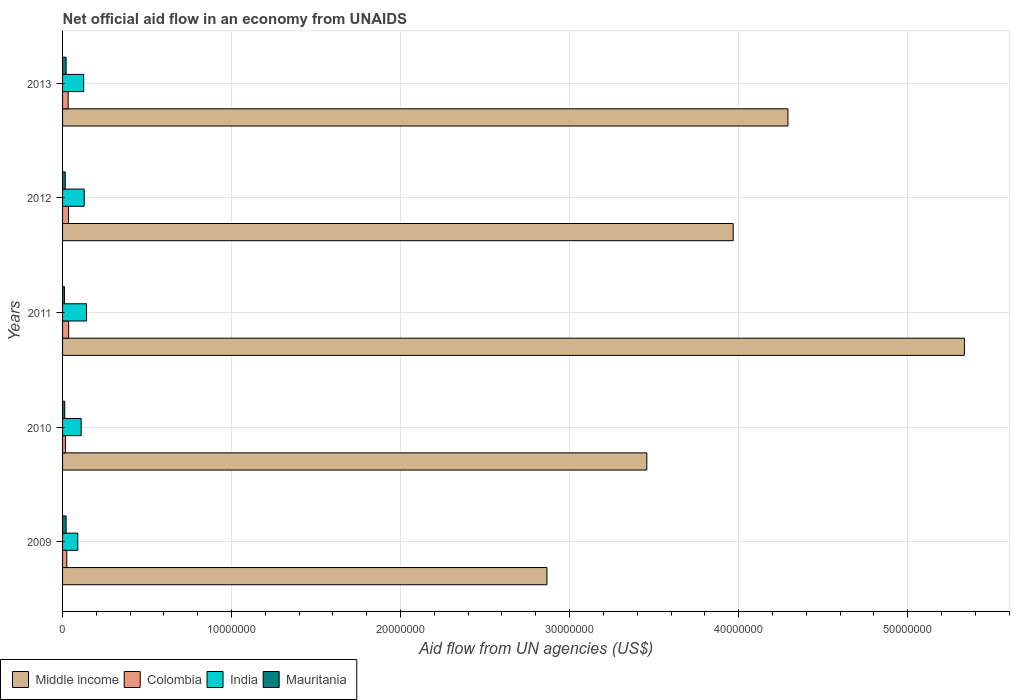How many different coloured bars are there?
Give a very brief answer. 4. Are the number of bars per tick equal to the number of legend labels?
Offer a very short reply. Yes. In how many cases, is the number of bars for a given year not equal to the number of legend labels?
Ensure brevity in your answer.  0. What is the net official aid flow in Middle income in 2009?
Offer a terse response. 2.87e+07. Across all years, what is the maximum net official aid flow in Middle income?
Your answer should be very brief. 5.34e+07. Across all years, what is the minimum net official aid flow in India?
Your answer should be very brief. 9.00e+05. In which year was the net official aid flow in Mauritania maximum?
Give a very brief answer. 2009. In which year was the net official aid flow in Mauritania minimum?
Offer a terse response. 2011. What is the total net official aid flow in Colombia in the graph?
Give a very brief answer. 1.46e+06. What is the difference between the net official aid flow in Colombia in 2010 and that in 2012?
Your answer should be compact. -1.80e+05. What is the difference between the net official aid flow in Colombia in 2011 and the net official aid flow in India in 2013?
Provide a succinct answer. -8.90e+05. What is the average net official aid flow in India per year?
Your answer should be compact. 1.19e+06. In the year 2012, what is the difference between the net official aid flow in Mauritania and net official aid flow in Middle income?
Make the answer very short. -3.95e+07. In how many years, is the net official aid flow in Colombia greater than 32000000 US$?
Make the answer very short. 0. What is the ratio of the net official aid flow in Middle income in 2009 to that in 2011?
Make the answer very short. 0.54. Is the difference between the net official aid flow in Mauritania in 2011 and 2013 greater than the difference between the net official aid flow in Middle income in 2011 and 2013?
Your response must be concise. No. What is the difference between the highest and the lowest net official aid flow in India?
Give a very brief answer. 5.20e+05. In how many years, is the net official aid flow in Colombia greater than the average net official aid flow in Colombia taken over all years?
Your response must be concise. 3. Is the sum of the net official aid flow in Mauritania in 2010 and 2012 greater than the maximum net official aid flow in Middle income across all years?
Offer a very short reply. No. What does the 4th bar from the bottom in 2011 represents?
Give a very brief answer. Mauritania. Is it the case that in every year, the sum of the net official aid flow in India and net official aid flow in Middle income is greater than the net official aid flow in Mauritania?
Provide a short and direct response. Yes. How many bars are there?
Ensure brevity in your answer.  20. Are all the bars in the graph horizontal?
Offer a very short reply. Yes. How many years are there in the graph?
Ensure brevity in your answer.  5. What is the difference between two consecutive major ticks on the X-axis?
Offer a terse response. 1.00e+07. Does the graph contain grids?
Offer a very short reply. Yes. Where does the legend appear in the graph?
Offer a very short reply. Bottom left. What is the title of the graph?
Offer a terse response. Net official aid flow in an economy from UNAIDS. Does "Barbados" appear as one of the legend labels in the graph?
Your response must be concise. No. What is the label or title of the X-axis?
Give a very brief answer. Aid flow from UN agencies (US$). What is the label or title of the Y-axis?
Provide a succinct answer. Years. What is the Aid flow from UN agencies (US$) in Middle income in 2009?
Keep it short and to the point. 2.87e+07. What is the Aid flow from UN agencies (US$) in Middle income in 2010?
Your answer should be compact. 3.46e+07. What is the Aid flow from UN agencies (US$) in India in 2010?
Ensure brevity in your answer.  1.10e+06. What is the Aid flow from UN agencies (US$) of Mauritania in 2010?
Make the answer very short. 1.30e+05. What is the Aid flow from UN agencies (US$) of Middle income in 2011?
Offer a very short reply. 5.34e+07. What is the Aid flow from UN agencies (US$) in India in 2011?
Ensure brevity in your answer.  1.42e+06. What is the Aid flow from UN agencies (US$) of Mauritania in 2011?
Offer a terse response. 1.10e+05. What is the Aid flow from UN agencies (US$) in Middle income in 2012?
Give a very brief answer. 3.97e+07. What is the Aid flow from UN agencies (US$) of India in 2012?
Offer a terse response. 1.28e+06. What is the Aid flow from UN agencies (US$) in Mauritania in 2012?
Give a very brief answer. 1.60e+05. What is the Aid flow from UN agencies (US$) of Middle income in 2013?
Your answer should be compact. 4.29e+07. What is the Aid flow from UN agencies (US$) of Colombia in 2013?
Offer a very short reply. 3.30e+05. What is the Aid flow from UN agencies (US$) of India in 2013?
Provide a short and direct response. 1.25e+06. What is the Aid flow from UN agencies (US$) in Mauritania in 2013?
Provide a short and direct response. 2.10e+05. Across all years, what is the maximum Aid flow from UN agencies (US$) in Middle income?
Your answer should be compact. 5.34e+07. Across all years, what is the maximum Aid flow from UN agencies (US$) in Colombia?
Ensure brevity in your answer.  3.60e+05. Across all years, what is the maximum Aid flow from UN agencies (US$) of India?
Your answer should be compact. 1.42e+06. Across all years, what is the minimum Aid flow from UN agencies (US$) of Middle income?
Give a very brief answer. 2.87e+07. What is the total Aid flow from UN agencies (US$) of Middle income in the graph?
Ensure brevity in your answer.  1.99e+08. What is the total Aid flow from UN agencies (US$) in Colombia in the graph?
Your response must be concise. 1.46e+06. What is the total Aid flow from UN agencies (US$) in India in the graph?
Provide a succinct answer. 5.95e+06. What is the total Aid flow from UN agencies (US$) of Mauritania in the graph?
Your response must be concise. 8.20e+05. What is the difference between the Aid flow from UN agencies (US$) in Middle income in 2009 and that in 2010?
Make the answer very short. -5.91e+06. What is the difference between the Aid flow from UN agencies (US$) of Colombia in 2009 and that in 2010?
Your answer should be compact. 8.00e+04. What is the difference between the Aid flow from UN agencies (US$) in India in 2009 and that in 2010?
Provide a short and direct response. -2.00e+05. What is the difference between the Aid flow from UN agencies (US$) in Middle income in 2009 and that in 2011?
Make the answer very short. -2.47e+07. What is the difference between the Aid flow from UN agencies (US$) in Colombia in 2009 and that in 2011?
Provide a succinct answer. -1.10e+05. What is the difference between the Aid flow from UN agencies (US$) of India in 2009 and that in 2011?
Your answer should be very brief. -5.20e+05. What is the difference between the Aid flow from UN agencies (US$) in Mauritania in 2009 and that in 2011?
Provide a short and direct response. 1.00e+05. What is the difference between the Aid flow from UN agencies (US$) in Middle income in 2009 and that in 2012?
Ensure brevity in your answer.  -1.10e+07. What is the difference between the Aid flow from UN agencies (US$) in India in 2009 and that in 2012?
Ensure brevity in your answer.  -3.80e+05. What is the difference between the Aid flow from UN agencies (US$) in Mauritania in 2009 and that in 2012?
Provide a short and direct response. 5.00e+04. What is the difference between the Aid flow from UN agencies (US$) of Middle income in 2009 and that in 2013?
Keep it short and to the point. -1.43e+07. What is the difference between the Aid flow from UN agencies (US$) of Colombia in 2009 and that in 2013?
Give a very brief answer. -8.00e+04. What is the difference between the Aid flow from UN agencies (US$) in India in 2009 and that in 2013?
Keep it short and to the point. -3.50e+05. What is the difference between the Aid flow from UN agencies (US$) of Middle income in 2010 and that in 2011?
Provide a succinct answer. -1.88e+07. What is the difference between the Aid flow from UN agencies (US$) in Colombia in 2010 and that in 2011?
Make the answer very short. -1.90e+05. What is the difference between the Aid flow from UN agencies (US$) of India in 2010 and that in 2011?
Your answer should be compact. -3.20e+05. What is the difference between the Aid flow from UN agencies (US$) in Middle income in 2010 and that in 2012?
Your answer should be compact. -5.11e+06. What is the difference between the Aid flow from UN agencies (US$) of Middle income in 2010 and that in 2013?
Give a very brief answer. -8.35e+06. What is the difference between the Aid flow from UN agencies (US$) in Colombia in 2010 and that in 2013?
Your answer should be compact. -1.60e+05. What is the difference between the Aid flow from UN agencies (US$) of Middle income in 2011 and that in 2012?
Your answer should be very brief. 1.37e+07. What is the difference between the Aid flow from UN agencies (US$) of Colombia in 2011 and that in 2012?
Provide a short and direct response. 10000. What is the difference between the Aid flow from UN agencies (US$) of India in 2011 and that in 2012?
Give a very brief answer. 1.40e+05. What is the difference between the Aid flow from UN agencies (US$) in Middle income in 2011 and that in 2013?
Your response must be concise. 1.04e+07. What is the difference between the Aid flow from UN agencies (US$) of India in 2011 and that in 2013?
Keep it short and to the point. 1.70e+05. What is the difference between the Aid flow from UN agencies (US$) of Mauritania in 2011 and that in 2013?
Make the answer very short. -1.00e+05. What is the difference between the Aid flow from UN agencies (US$) in Middle income in 2012 and that in 2013?
Your answer should be very brief. -3.24e+06. What is the difference between the Aid flow from UN agencies (US$) in India in 2012 and that in 2013?
Provide a short and direct response. 3.00e+04. What is the difference between the Aid flow from UN agencies (US$) in Mauritania in 2012 and that in 2013?
Provide a succinct answer. -5.00e+04. What is the difference between the Aid flow from UN agencies (US$) in Middle income in 2009 and the Aid flow from UN agencies (US$) in Colombia in 2010?
Your answer should be compact. 2.85e+07. What is the difference between the Aid flow from UN agencies (US$) in Middle income in 2009 and the Aid flow from UN agencies (US$) in India in 2010?
Keep it short and to the point. 2.76e+07. What is the difference between the Aid flow from UN agencies (US$) in Middle income in 2009 and the Aid flow from UN agencies (US$) in Mauritania in 2010?
Your response must be concise. 2.85e+07. What is the difference between the Aid flow from UN agencies (US$) in Colombia in 2009 and the Aid flow from UN agencies (US$) in India in 2010?
Your response must be concise. -8.50e+05. What is the difference between the Aid flow from UN agencies (US$) in Colombia in 2009 and the Aid flow from UN agencies (US$) in Mauritania in 2010?
Offer a very short reply. 1.20e+05. What is the difference between the Aid flow from UN agencies (US$) in India in 2009 and the Aid flow from UN agencies (US$) in Mauritania in 2010?
Give a very brief answer. 7.70e+05. What is the difference between the Aid flow from UN agencies (US$) in Middle income in 2009 and the Aid flow from UN agencies (US$) in Colombia in 2011?
Give a very brief answer. 2.83e+07. What is the difference between the Aid flow from UN agencies (US$) in Middle income in 2009 and the Aid flow from UN agencies (US$) in India in 2011?
Your response must be concise. 2.72e+07. What is the difference between the Aid flow from UN agencies (US$) of Middle income in 2009 and the Aid flow from UN agencies (US$) of Mauritania in 2011?
Your answer should be compact. 2.86e+07. What is the difference between the Aid flow from UN agencies (US$) of Colombia in 2009 and the Aid flow from UN agencies (US$) of India in 2011?
Give a very brief answer. -1.17e+06. What is the difference between the Aid flow from UN agencies (US$) of India in 2009 and the Aid flow from UN agencies (US$) of Mauritania in 2011?
Offer a terse response. 7.90e+05. What is the difference between the Aid flow from UN agencies (US$) in Middle income in 2009 and the Aid flow from UN agencies (US$) in Colombia in 2012?
Provide a short and direct response. 2.83e+07. What is the difference between the Aid flow from UN agencies (US$) in Middle income in 2009 and the Aid flow from UN agencies (US$) in India in 2012?
Your answer should be very brief. 2.74e+07. What is the difference between the Aid flow from UN agencies (US$) in Middle income in 2009 and the Aid flow from UN agencies (US$) in Mauritania in 2012?
Make the answer very short. 2.85e+07. What is the difference between the Aid flow from UN agencies (US$) in Colombia in 2009 and the Aid flow from UN agencies (US$) in India in 2012?
Your answer should be compact. -1.03e+06. What is the difference between the Aid flow from UN agencies (US$) in India in 2009 and the Aid flow from UN agencies (US$) in Mauritania in 2012?
Make the answer very short. 7.40e+05. What is the difference between the Aid flow from UN agencies (US$) in Middle income in 2009 and the Aid flow from UN agencies (US$) in Colombia in 2013?
Make the answer very short. 2.83e+07. What is the difference between the Aid flow from UN agencies (US$) in Middle income in 2009 and the Aid flow from UN agencies (US$) in India in 2013?
Offer a very short reply. 2.74e+07. What is the difference between the Aid flow from UN agencies (US$) in Middle income in 2009 and the Aid flow from UN agencies (US$) in Mauritania in 2013?
Your answer should be compact. 2.84e+07. What is the difference between the Aid flow from UN agencies (US$) of Colombia in 2009 and the Aid flow from UN agencies (US$) of India in 2013?
Keep it short and to the point. -1.00e+06. What is the difference between the Aid flow from UN agencies (US$) of India in 2009 and the Aid flow from UN agencies (US$) of Mauritania in 2013?
Make the answer very short. 6.90e+05. What is the difference between the Aid flow from UN agencies (US$) in Middle income in 2010 and the Aid flow from UN agencies (US$) in Colombia in 2011?
Your response must be concise. 3.42e+07. What is the difference between the Aid flow from UN agencies (US$) in Middle income in 2010 and the Aid flow from UN agencies (US$) in India in 2011?
Keep it short and to the point. 3.32e+07. What is the difference between the Aid flow from UN agencies (US$) of Middle income in 2010 and the Aid flow from UN agencies (US$) of Mauritania in 2011?
Keep it short and to the point. 3.45e+07. What is the difference between the Aid flow from UN agencies (US$) in Colombia in 2010 and the Aid flow from UN agencies (US$) in India in 2011?
Offer a terse response. -1.25e+06. What is the difference between the Aid flow from UN agencies (US$) of India in 2010 and the Aid flow from UN agencies (US$) of Mauritania in 2011?
Your answer should be compact. 9.90e+05. What is the difference between the Aid flow from UN agencies (US$) of Middle income in 2010 and the Aid flow from UN agencies (US$) of Colombia in 2012?
Provide a short and direct response. 3.42e+07. What is the difference between the Aid flow from UN agencies (US$) of Middle income in 2010 and the Aid flow from UN agencies (US$) of India in 2012?
Keep it short and to the point. 3.33e+07. What is the difference between the Aid flow from UN agencies (US$) in Middle income in 2010 and the Aid flow from UN agencies (US$) in Mauritania in 2012?
Give a very brief answer. 3.44e+07. What is the difference between the Aid flow from UN agencies (US$) of Colombia in 2010 and the Aid flow from UN agencies (US$) of India in 2012?
Ensure brevity in your answer.  -1.11e+06. What is the difference between the Aid flow from UN agencies (US$) of India in 2010 and the Aid flow from UN agencies (US$) of Mauritania in 2012?
Your answer should be compact. 9.40e+05. What is the difference between the Aid flow from UN agencies (US$) in Middle income in 2010 and the Aid flow from UN agencies (US$) in Colombia in 2013?
Offer a very short reply. 3.42e+07. What is the difference between the Aid flow from UN agencies (US$) in Middle income in 2010 and the Aid flow from UN agencies (US$) in India in 2013?
Provide a short and direct response. 3.33e+07. What is the difference between the Aid flow from UN agencies (US$) in Middle income in 2010 and the Aid flow from UN agencies (US$) in Mauritania in 2013?
Provide a short and direct response. 3.44e+07. What is the difference between the Aid flow from UN agencies (US$) of Colombia in 2010 and the Aid flow from UN agencies (US$) of India in 2013?
Provide a succinct answer. -1.08e+06. What is the difference between the Aid flow from UN agencies (US$) in India in 2010 and the Aid flow from UN agencies (US$) in Mauritania in 2013?
Ensure brevity in your answer.  8.90e+05. What is the difference between the Aid flow from UN agencies (US$) of Middle income in 2011 and the Aid flow from UN agencies (US$) of Colombia in 2012?
Your answer should be very brief. 5.30e+07. What is the difference between the Aid flow from UN agencies (US$) of Middle income in 2011 and the Aid flow from UN agencies (US$) of India in 2012?
Your response must be concise. 5.21e+07. What is the difference between the Aid flow from UN agencies (US$) in Middle income in 2011 and the Aid flow from UN agencies (US$) in Mauritania in 2012?
Offer a terse response. 5.32e+07. What is the difference between the Aid flow from UN agencies (US$) in Colombia in 2011 and the Aid flow from UN agencies (US$) in India in 2012?
Make the answer very short. -9.20e+05. What is the difference between the Aid flow from UN agencies (US$) of India in 2011 and the Aid flow from UN agencies (US$) of Mauritania in 2012?
Your answer should be very brief. 1.26e+06. What is the difference between the Aid flow from UN agencies (US$) of Middle income in 2011 and the Aid flow from UN agencies (US$) of Colombia in 2013?
Ensure brevity in your answer.  5.30e+07. What is the difference between the Aid flow from UN agencies (US$) of Middle income in 2011 and the Aid flow from UN agencies (US$) of India in 2013?
Make the answer very short. 5.21e+07. What is the difference between the Aid flow from UN agencies (US$) in Middle income in 2011 and the Aid flow from UN agencies (US$) in Mauritania in 2013?
Provide a short and direct response. 5.32e+07. What is the difference between the Aid flow from UN agencies (US$) of Colombia in 2011 and the Aid flow from UN agencies (US$) of India in 2013?
Keep it short and to the point. -8.90e+05. What is the difference between the Aid flow from UN agencies (US$) in India in 2011 and the Aid flow from UN agencies (US$) in Mauritania in 2013?
Keep it short and to the point. 1.21e+06. What is the difference between the Aid flow from UN agencies (US$) in Middle income in 2012 and the Aid flow from UN agencies (US$) in Colombia in 2013?
Your response must be concise. 3.94e+07. What is the difference between the Aid flow from UN agencies (US$) in Middle income in 2012 and the Aid flow from UN agencies (US$) in India in 2013?
Your answer should be very brief. 3.84e+07. What is the difference between the Aid flow from UN agencies (US$) of Middle income in 2012 and the Aid flow from UN agencies (US$) of Mauritania in 2013?
Keep it short and to the point. 3.95e+07. What is the difference between the Aid flow from UN agencies (US$) of Colombia in 2012 and the Aid flow from UN agencies (US$) of India in 2013?
Provide a succinct answer. -9.00e+05. What is the difference between the Aid flow from UN agencies (US$) in India in 2012 and the Aid flow from UN agencies (US$) in Mauritania in 2013?
Your answer should be very brief. 1.07e+06. What is the average Aid flow from UN agencies (US$) in Middle income per year?
Keep it short and to the point. 3.98e+07. What is the average Aid flow from UN agencies (US$) in Colombia per year?
Provide a short and direct response. 2.92e+05. What is the average Aid flow from UN agencies (US$) of India per year?
Keep it short and to the point. 1.19e+06. What is the average Aid flow from UN agencies (US$) in Mauritania per year?
Offer a very short reply. 1.64e+05. In the year 2009, what is the difference between the Aid flow from UN agencies (US$) of Middle income and Aid flow from UN agencies (US$) of Colombia?
Make the answer very short. 2.84e+07. In the year 2009, what is the difference between the Aid flow from UN agencies (US$) of Middle income and Aid flow from UN agencies (US$) of India?
Your response must be concise. 2.78e+07. In the year 2009, what is the difference between the Aid flow from UN agencies (US$) in Middle income and Aid flow from UN agencies (US$) in Mauritania?
Your response must be concise. 2.84e+07. In the year 2009, what is the difference between the Aid flow from UN agencies (US$) in Colombia and Aid flow from UN agencies (US$) in India?
Your response must be concise. -6.50e+05. In the year 2009, what is the difference between the Aid flow from UN agencies (US$) of India and Aid flow from UN agencies (US$) of Mauritania?
Your answer should be very brief. 6.90e+05. In the year 2010, what is the difference between the Aid flow from UN agencies (US$) of Middle income and Aid flow from UN agencies (US$) of Colombia?
Provide a succinct answer. 3.44e+07. In the year 2010, what is the difference between the Aid flow from UN agencies (US$) of Middle income and Aid flow from UN agencies (US$) of India?
Your answer should be compact. 3.35e+07. In the year 2010, what is the difference between the Aid flow from UN agencies (US$) of Middle income and Aid flow from UN agencies (US$) of Mauritania?
Make the answer very short. 3.44e+07. In the year 2010, what is the difference between the Aid flow from UN agencies (US$) in Colombia and Aid flow from UN agencies (US$) in India?
Keep it short and to the point. -9.30e+05. In the year 2010, what is the difference between the Aid flow from UN agencies (US$) of Colombia and Aid flow from UN agencies (US$) of Mauritania?
Offer a very short reply. 4.00e+04. In the year 2010, what is the difference between the Aid flow from UN agencies (US$) in India and Aid flow from UN agencies (US$) in Mauritania?
Provide a short and direct response. 9.70e+05. In the year 2011, what is the difference between the Aid flow from UN agencies (US$) in Middle income and Aid flow from UN agencies (US$) in Colombia?
Your response must be concise. 5.30e+07. In the year 2011, what is the difference between the Aid flow from UN agencies (US$) in Middle income and Aid flow from UN agencies (US$) in India?
Ensure brevity in your answer.  5.19e+07. In the year 2011, what is the difference between the Aid flow from UN agencies (US$) of Middle income and Aid flow from UN agencies (US$) of Mauritania?
Give a very brief answer. 5.32e+07. In the year 2011, what is the difference between the Aid flow from UN agencies (US$) of Colombia and Aid flow from UN agencies (US$) of India?
Ensure brevity in your answer.  -1.06e+06. In the year 2011, what is the difference between the Aid flow from UN agencies (US$) in Colombia and Aid flow from UN agencies (US$) in Mauritania?
Make the answer very short. 2.50e+05. In the year 2011, what is the difference between the Aid flow from UN agencies (US$) of India and Aid flow from UN agencies (US$) of Mauritania?
Make the answer very short. 1.31e+06. In the year 2012, what is the difference between the Aid flow from UN agencies (US$) of Middle income and Aid flow from UN agencies (US$) of Colombia?
Offer a very short reply. 3.93e+07. In the year 2012, what is the difference between the Aid flow from UN agencies (US$) in Middle income and Aid flow from UN agencies (US$) in India?
Keep it short and to the point. 3.84e+07. In the year 2012, what is the difference between the Aid flow from UN agencies (US$) of Middle income and Aid flow from UN agencies (US$) of Mauritania?
Offer a very short reply. 3.95e+07. In the year 2012, what is the difference between the Aid flow from UN agencies (US$) in Colombia and Aid flow from UN agencies (US$) in India?
Your answer should be compact. -9.30e+05. In the year 2012, what is the difference between the Aid flow from UN agencies (US$) of India and Aid flow from UN agencies (US$) of Mauritania?
Offer a terse response. 1.12e+06. In the year 2013, what is the difference between the Aid flow from UN agencies (US$) in Middle income and Aid flow from UN agencies (US$) in Colombia?
Ensure brevity in your answer.  4.26e+07. In the year 2013, what is the difference between the Aid flow from UN agencies (US$) in Middle income and Aid flow from UN agencies (US$) in India?
Ensure brevity in your answer.  4.17e+07. In the year 2013, what is the difference between the Aid flow from UN agencies (US$) in Middle income and Aid flow from UN agencies (US$) in Mauritania?
Your response must be concise. 4.27e+07. In the year 2013, what is the difference between the Aid flow from UN agencies (US$) of Colombia and Aid flow from UN agencies (US$) of India?
Provide a succinct answer. -9.20e+05. In the year 2013, what is the difference between the Aid flow from UN agencies (US$) in India and Aid flow from UN agencies (US$) in Mauritania?
Offer a very short reply. 1.04e+06. What is the ratio of the Aid flow from UN agencies (US$) in Middle income in 2009 to that in 2010?
Your answer should be very brief. 0.83. What is the ratio of the Aid flow from UN agencies (US$) of Colombia in 2009 to that in 2010?
Your response must be concise. 1.47. What is the ratio of the Aid flow from UN agencies (US$) in India in 2009 to that in 2010?
Give a very brief answer. 0.82. What is the ratio of the Aid flow from UN agencies (US$) of Mauritania in 2009 to that in 2010?
Keep it short and to the point. 1.62. What is the ratio of the Aid flow from UN agencies (US$) of Middle income in 2009 to that in 2011?
Offer a terse response. 0.54. What is the ratio of the Aid flow from UN agencies (US$) of Colombia in 2009 to that in 2011?
Give a very brief answer. 0.69. What is the ratio of the Aid flow from UN agencies (US$) of India in 2009 to that in 2011?
Your answer should be compact. 0.63. What is the ratio of the Aid flow from UN agencies (US$) in Mauritania in 2009 to that in 2011?
Keep it short and to the point. 1.91. What is the ratio of the Aid flow from UN agencies (US$) in Middle income in 2009 to that in 2012?
Offer a very short reply. 0.72. What is the ratio of the Aid flow from UN agencies (US$) in India in 2009 to that in 2012?
Your response must be concise. 0.7. What is the ratio of the Aid flow from UN agencies (US$) of Mauritania in 2009 to that in 2012?
Keep it short and to the point. 1.31. What is the ratio of the Aid flow from UN agencies (US$) in Middle income in 2009 to that in 2013?
Provide a succinct answer. 0.67. What is the ratio of the Aid flow from UN agencies (US$) in Colombia in 2009 to that in 2013?
Offer a terse response. 0.76. What is the ratio of the Aid flow from UN agencies (US$) in India in 2009 to that in 2013?
Ensure brevity in your answer.  0.72. What is the ratio of the Aid flow from UN agencies (US$) of Middle income in 2010 to that in 2011?
Your answer should be compact. 0.65. What is the ratio of the Aid flow from UN agencies (US$) of Colombia in 2010 to that in 2011?
Give a very brief answer. 0.47. What is the ratio of the Aid flow from UN agencies (US$) of India in 2010 to that in 2011?
Ensure brevity in your answer.  0.77. What is the ratio of the Aid flow from UN agencies (US$) of Mauritania in 2010 to that in 2011?
Ensure brevity in your answer.  1.18. What is the ratio of the Aid flow from UN agencies (US$) in Middle income in 2010 to that in 2012?
Provide a succinct answer. 0.87. What is the ratio of the Aid flow from UN agencies (US$) of Colombia in 2010 to that in 2012?
Your response must be concise. 0.49. What is the ratio of the Aid flow from UN agencies (US$) in India in 2010 to that in 2012?
Make the answer very short. 0.86. What is the ratio of the Aid flow from UN agencies (US$) in Mauritania in 2010 to that in 2012?
Provide a succinct answer. 0.81. What is the ratio of the Aid flow from UN agencies (US$) of Middle income in 2010 to that in 2013?
Your response must be concise. 0.81. What is the ratio of the Aid flow from UN agencies (US$) of Colombia in 2010 to that in 2013?
Offer a very short reply. 0.52. What is the ratio of the Aid flow from UN agencies (US$) in Mauritania in 2010 to that in 2013?
Provide a succinct answer. 0.62. What is the ratio of the Aid flow from UN agencies (US$) in Middle income in 2011 to that in 2012?
Give a very brief answer. 1.34. What is the ratio of the Aid flow from UN agencies (US$) in Colombia in 2011 to that in 2012?
Your answer should be compact. 1.03. What is the ratio of the Aid flow from UN agencies (US$) of India in 2011 to that in 2012?
Offer a terse response. 1.11. What is the ratio of the Aid flow from UN agencies (US$) in Mauritania in 2011 to that in 2012?
Give a very brief answer. 0.69. What is the ratio of the Aid flow from UN agencies (US$) of Middle income in 2011 to that in 2013?
Give a very brief answer. 1.24. What is the ratio of the Aid flow from UN agencies (US$) of Colombia in 2011 to that in 2013?
Your answer should be very brief. 1.09. What is the ratio of the Aid flow from UN agencies (US$) in India in 2011 to that in 2013?
Offer a terse response. 1.14. What is the ratio of the Aid flow from UN agencies (US$) of Mauritania in 2011 to that in 2013?
Offer a very short reply. 0.52. What is the ratio of the Aid flow from UN agencies (US$) in Middle income in 2012 to that in 2013?
Offer a very short reply. 0.92. What is the ratio of the Aid flow from UN agencies (US$) in Colombia in 2012 to that in 2013?
Your answer should be compact. 1.06. What is the ratio of the Aid flow from UN agencies (US$) of Mauritania in 2012 to that in 2013?
Ensure brevity in your answer.  0.76. What is the difference between the highest and the second highest Aid flow from UN agencies (US$) in Middle income?
Make the answer very short. 1.04e+07. What is the difference between the highest and the second highest Aid flow from UN agencies (US$) in India?
Your answer should be very brief. 1.40e+05. What is the difference between the highest and the lowest Aid flow from UN agencies (US$) in Middle income?
Offer a very short reply. 2.47e+07. What is the difference between the highest and the lowest Aid flow from UN agencies (US$) of India?
Offer a very short reply. 5.20e+05. 